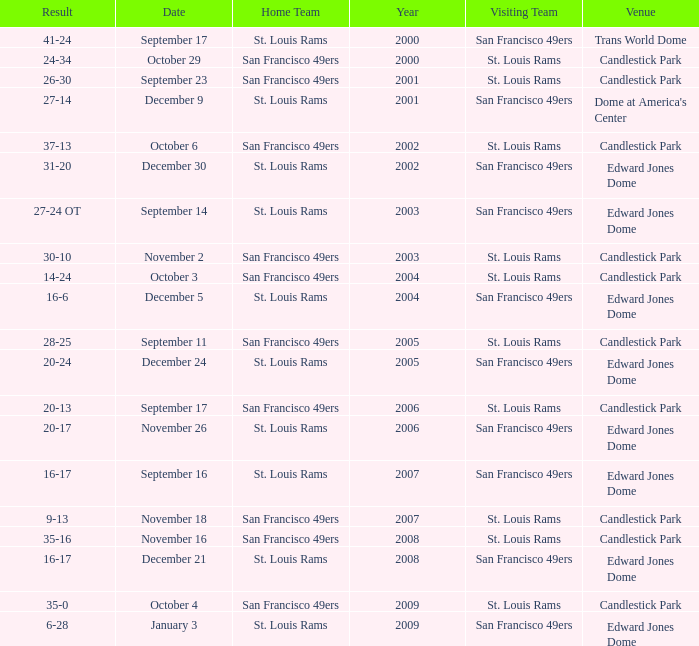What is the Venue of the 2009 St. Louis Rams Home game? Edward Jones Dome. 